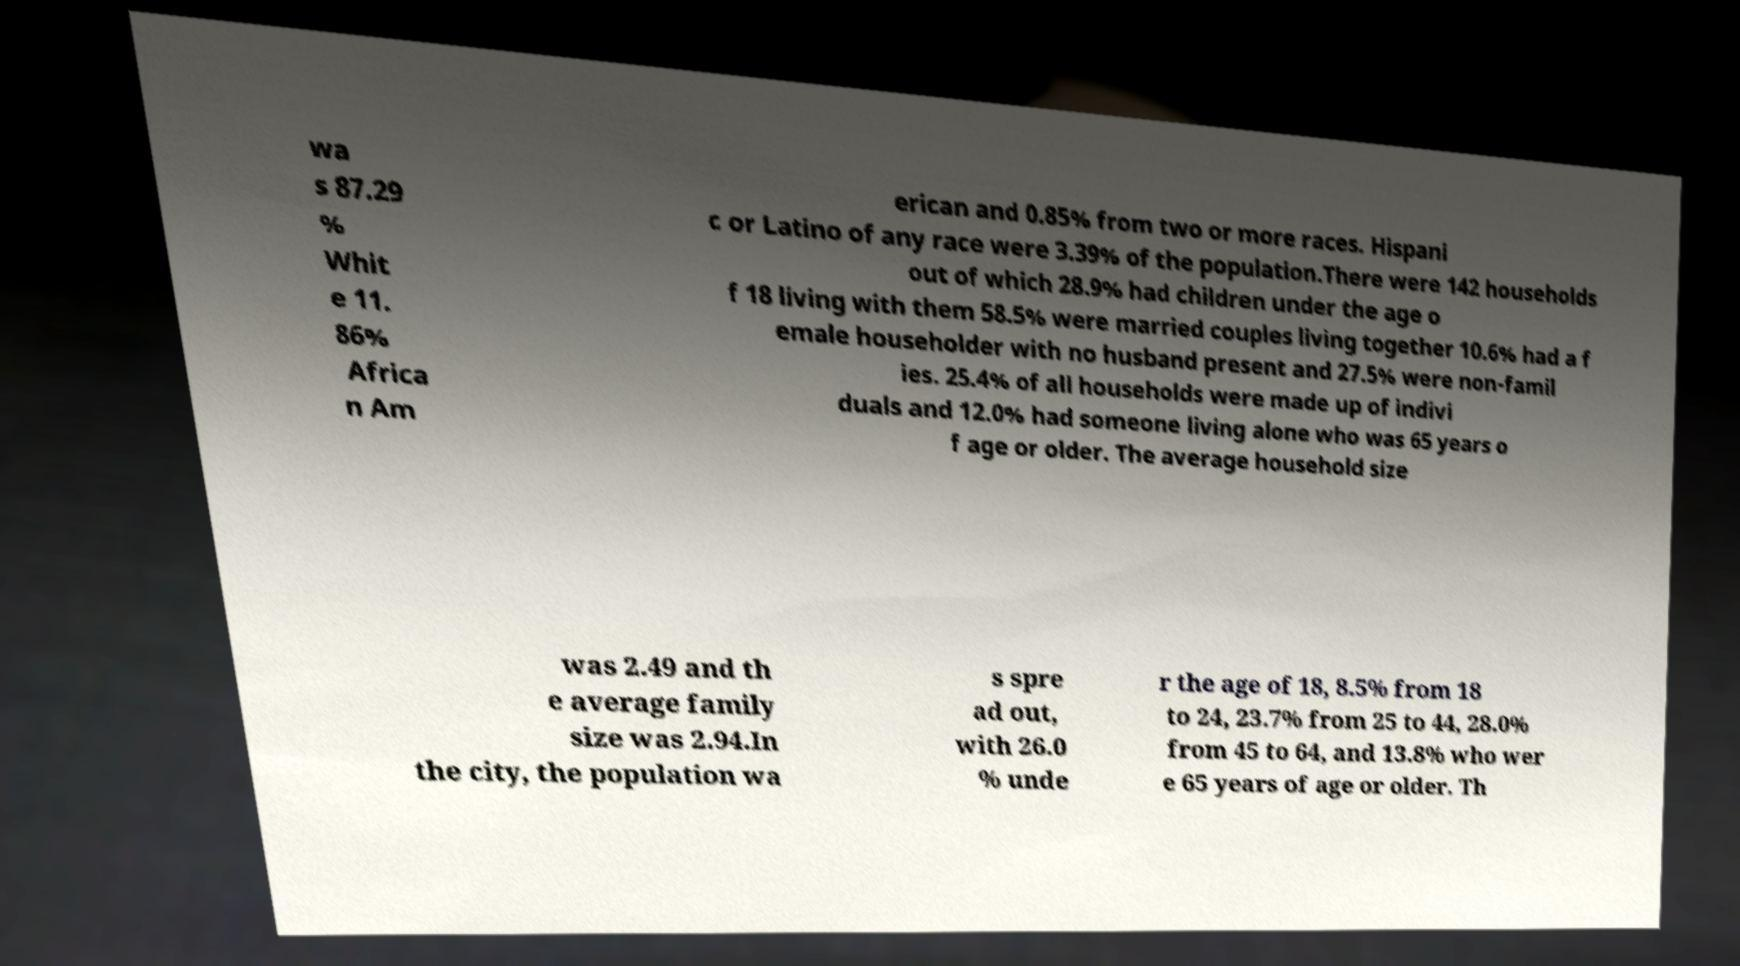Please read and relay the text visible in this image. What does it say? wa s 87.29 % Whit e 11. 86% Africa n Am erican and 0.85% from two or more races. Hispani c or Latino of any race were 3.39% of the population.There were 142 households out of which 28.9% had children under the age o f 18 living with them 58.5% were married couples living together 10.6% had a f emale householder with no husband present and 27.5% were non-famil ies. 25.4% of all households were made up of indivi duals and 12.0% had someone living alone who was 65 years o f age or older. The average household size was 2.49 and th e average family size was 2.94.In the city, the population wa s spre ad out, with 26.0 % unde r the age of 18, 8.5% from 18 to 24, 23.7% from 25 to 44, 28.0% from 45 to 64, and 13.8% who wer e 65 years of age or older. Th 